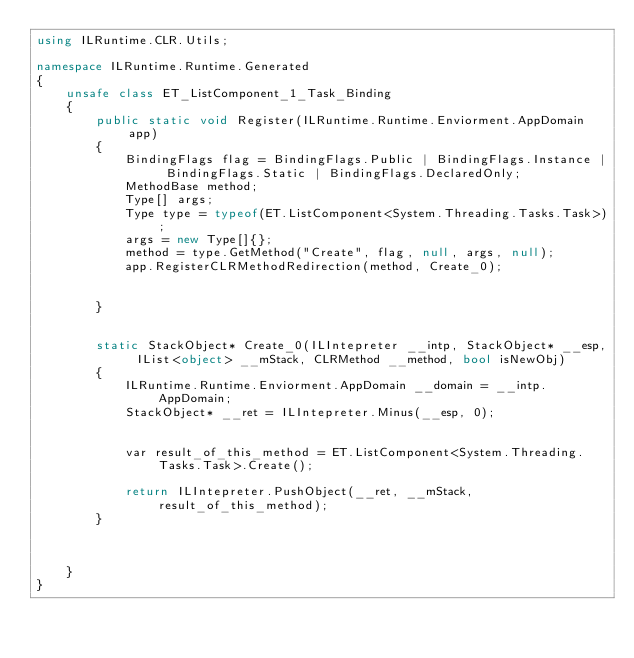<code> <loc_0><loc_0><loc_500><loc_500><_C#_>using ILRuntime.CLR.Utils;

namespace ILRuntime.Runtime.Generated
{
    unsafe class ET_ListComponent_1_Task_Binding
    {
        public static void Register(ILRuntime.Runtime.Enviorment.AppDomain app)
        {
            BindingFlags flag = BindingFlags.Public | BindingFlags.Instance | BindingFlags.Static | BindingFlags.DeclaredOnly;
            MethodBase method;
            Type[] args;
            Type type = typeof(ET.ListComponent<System.Threading.Tasks.Task>);
            args = new Type[]{};
            method = type.GetMethod("Create", flag, null, args, null);
            app.RegisterCLRMethodRedirection(method, Create_0);


        }


        static StackObject* Create_0(ILIntepreter __intp, StackObject* __esp, IList<object> __mStack, CLRMethod __method, bool isNewObj)
        {
            ILRuntime.Runtime.Enviorment.AppDomain __domain = __intp.AppDomain;
            StackObject* __ret = ILIntepreter.Minus(__esp, 0);


            var result_of_this_method = ET.ListComponent<System.Threading.Tasks.Task>.Create();

            return ILIntepreter.PushObject(__ret, __mStack, result_of_this_method);
        }



    }
}
</code> 